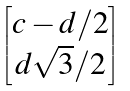Convert formula to latex. <formula><loc_0><loc_0><loc_500><loc_500>\begin{bmatrix} c - d / 2 \\ d \sqrt { 3 } / 2 \end{bmatrix}</formula> 